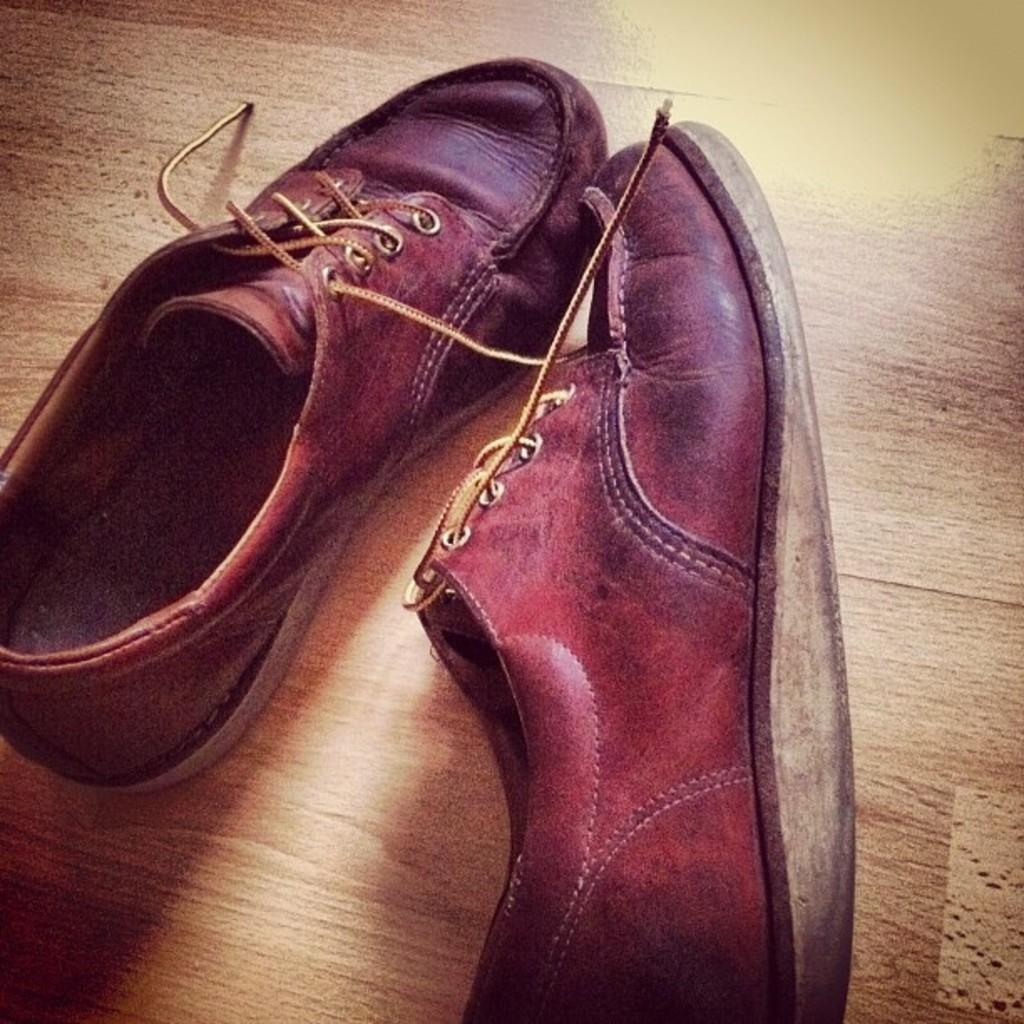What objects are present in the image? There are two shoes in the image. What color are the shoes? The shoes are brown in color. What is the shoes' location in the image? The shoes are on a brown surface. What type of spark can be seen coming from the shoes in the image? There is no spark present in the image; the shoes are simply resting on a brown surface. 